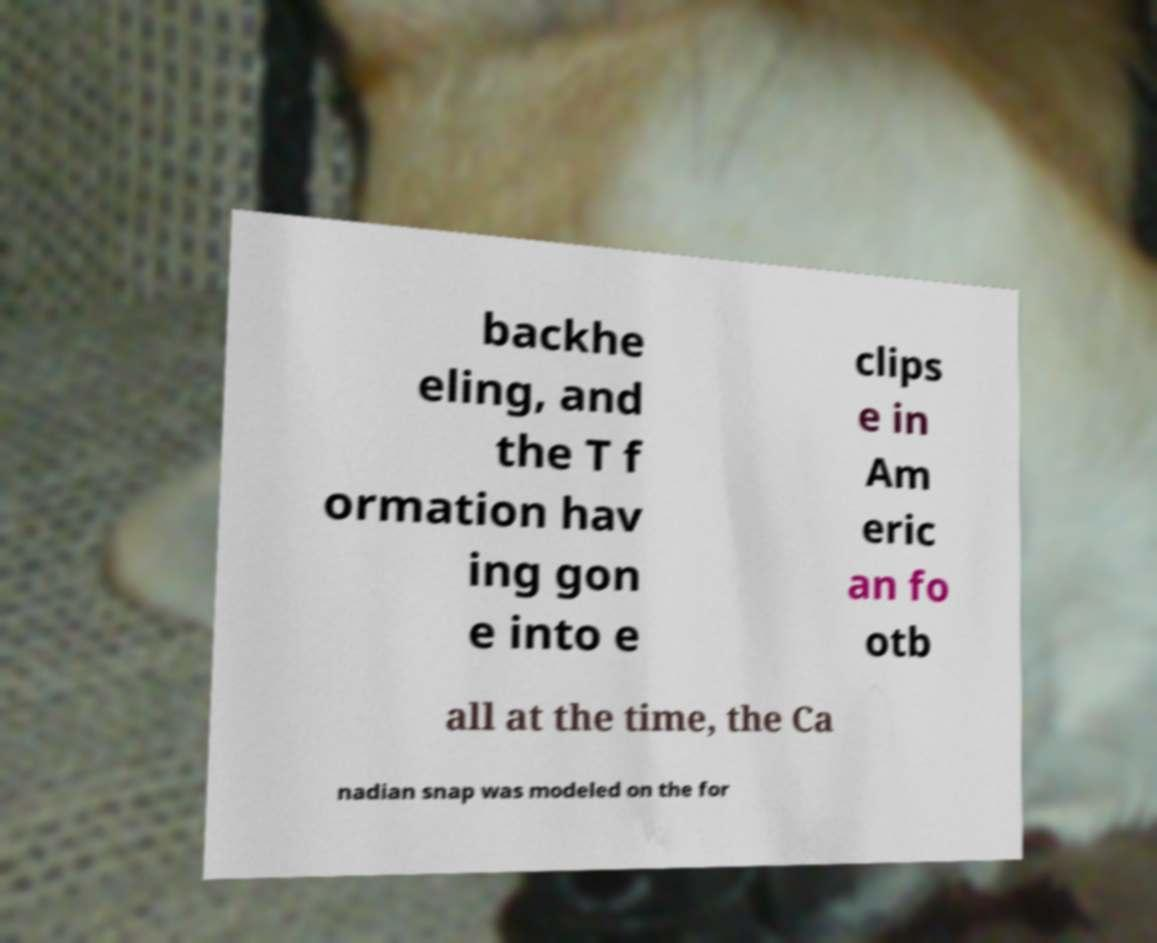Could you assist in decoding the text presented in this image and type it out clearly? backhe eling, and the T f ormation hav ing gon e into e clips e in Am eric an fo otb all at the time, the Ca nadian snap was modeled on the for 